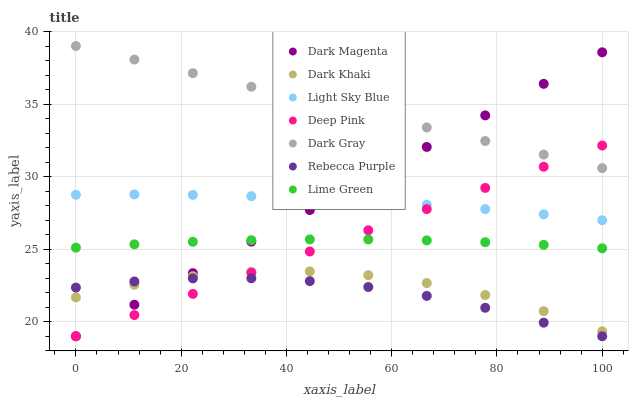Does Rebecca Purple have the minimum area under the curve?
Answer yes or no. Yes. Does Dark Gray have the maximum area under the curve?
Answer yes or no. Yes. Does Deep Pink have the minimum area under the curve?
Answer yes or no. No. Does Deep Pink have the maximum area under the curve?
Answer yes or no. No. Is Deep Pink the smoothest?
Answer yes or no. Yes. Is Dark Khaki the roughest?
Answer yes or no. Yes. Is Dark Magenta the smoothest?
Answer yes or no. No. Is Dark Magenta the roughest?
Answer yes or no. No. Does Deep Pink have the lowest value?
Answer yes or no. Yes. Does Dark Khaki have the lowest value?
Answer yes or no. No. Does Dark Gray have the highest value?
Answer yes or no. Yes. Does Deep Pink have the highest value?
Answer yes or no. No. Is Rebecca Purple less than Lime Green?
Answer yes or no. Yes. Is Dark Gray greater than Lime Green?
Answer yes or no. Yes. Does Rebecca Purple intersect Dark Khaki?
Answer yes or no. Yes. Is Rebecca Purple less than Dark Khaki?
Answer yes or no. No. Is Rebecca Purple greater than Dark Khaki?
Answer yes or no. No. Does Rebecca Purple intersect Lime Green?
Answer yes or no. No. 